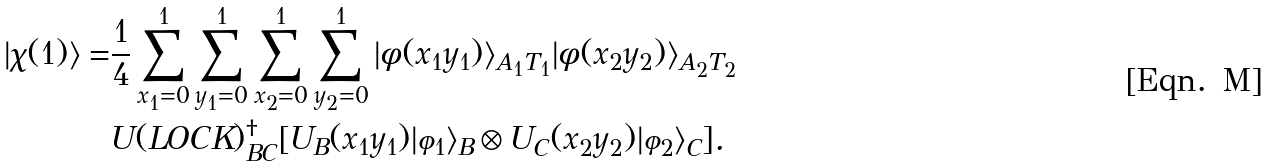Convert formula to latex. <formula><loc_0><loc_0><loc_500><loc_500>| \chi ( 1 ) \rangle = & \frac { 1 } { 4 } \sum _ { x _ { 1 } = 0 } ^ { 1 } \sum _ { y _ { 1 } = 0 } ^ { 1 } \sum _ { x _ { 2 } = 0 } ^ { 1 } \sum _ { y _ { 2 } = 0 } ^ { 1 } | \phi ( x _ { 1 } y _ { 1 } ) \rangle _ { A _ { 1 } T _ { 1 } } | \phi ( x _ { 2 } y _ { 2 } ) \rangle _ { A _ { 2 } T _ { 2 } } \\ & U ( L O C K ) ^ { \dagger } _ { B C } [ U _ { B } ( x _ { 1 } y _ { 1 } ) | \varphi _ { 1 } \rangle _ { B } \otimes U _ { C } ( x _ { 2 } y _ { 2 } ) | \varphi _ { 2 } \rangle _ { C } ] .</formula> 